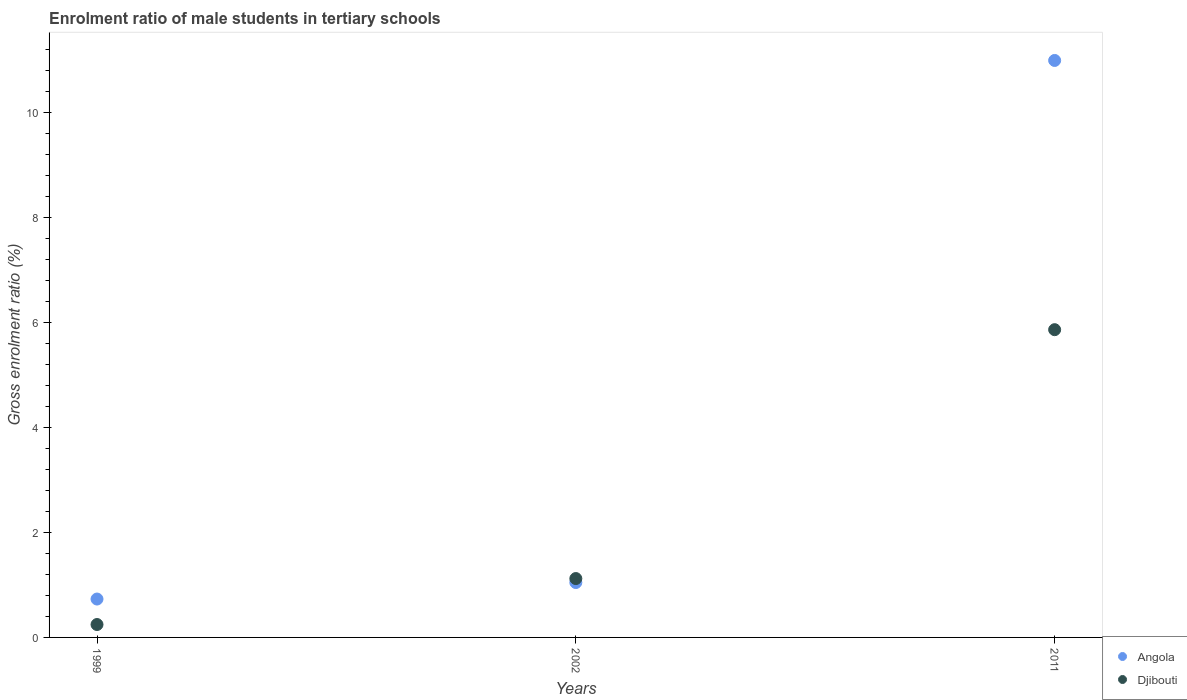How many different coloured dotlines are there?
Ensure brevity in your answer.  2. What is the enrolment ratio of male students in tertiary schools in Djibouti in 2011?
Offer a terse response. 5.86. Across all years, what is the maximum enrolment ratio of male students in tertiary schools in Angola?
Provide a succinct answer. 10.99. Across all years, what is the minimum enrolment ratio of male students in tertiary schools in Angola?
Ensure brevity in your answer.  0.73. In which year was the enrolment ratio of male students in tertiary schools in Djibouti maximum?
Offer a very short reply. 2011. What is the total enrolment ratio of male students in tertiary schools in Angola in the graph?
Your answer should be very brief. 12.76. What is the difference between the enrolment ratio of male students in tertiary schools in Djibouti in 2002 and that in 2011?
Give a very brief answer. -4.74. What is the difference between the enrolment ratio of male students in tertiary schools in Djibouti in 2011 and the enrolment ratio of male students in tertiary schools in Angola in 1999?
Give a very brief answer. 5.13. What is the average enrolment ratio of male students in tertiary schools in Angola per year?
Offer a very short reply. 4.25. In the year 2002, what is the difference between the enrolment ratio of male students in tertiary schools in Djibouti and enrolment ratio of male students in tertiary schools in Angola?
Offer a terse response. 0.08. What is the ratio of the enrolment ratio of male students in tertiary schools in Angola in 1999 to that in 2011?
Provide a short and direct response. 0.07. Is the difference between the enrolment ratio of male students in tertiary schools in Djibouti in 1999 and 2002 greater than the difference between the enrolment ratio of male students in tertiary schools in Angola in 1999 and 2002?
Ensure brevity in your answer.  No. What is the difference between the highest and the second highest enrolment ratio of male students in tertiary schools in Angola?
Your response must be concise. 9.94. What is the difference between the highest and the lowest enrolment ratio of male students in tertiary schools in Djibouti?
Provide a short and direct response. 5.61. Is the sum of the enrolment ratio of male students in tertiary schools in Angola in 1999 and 2002 greater than the maximum enrolment ratio of male students in tertiary schools in Djibouti across all years?
Your response must be concise. No. Does the enrolment ratio of male students in tertiary schools in Angola monotonically increase over the years?
Offer a terse response. Yes. Is the enrolment ratio of male students in tertiary schools in Angola strictly greater than the enrolment ratio of male students in tertiary schools in Djibouti over the years?
Offer a terse response. No. Is the enrolment ratio of male students in tertiary schools in Djibouti strictly less than the enrolment ratio of male students in tertiary schools in Angola over the years?
Provide a short and direct response. No. How many dotlines are there?
Give a very brief answer. 2. How many years are there in the graph?
Make the answer very short. 3. What is the difference between two consecutive major ticks on the Y-axis?
Provide a succinct answer. 2. Does the graph contain grids?
Give a very brief answer. No. Where does the legend appear in the graph?
Keep it short and to the point. Bottom right. How many legend labels are there?
Provide a succinct answer. 2. How are the legend labels stacked?
Your answer should be compact. Vertical. What is the title of the graph?
Your answer should be very brief. Enrolment ratio of male students in tertiary schools. Does "Libya" appear as one of the legend labels in the graph?
Give a very brief answer. No. What is the label or title of the X-axis?
Offer a very short reply. Years. What is the label or title of the Y-axis?
Your response must be concise. Gross enrolment ratio (%). What is the Gross enrolment ratio (%) of Angola in 1999?
Your answer should be very brief. 0.73. What is the Gross enrolment ratio (%) in Djibouti in 1999?
Offer a very short reply. 0.25. What is the Gross enrolment ratio (%) of Angola in 2002?
Your answer should be compact. 1.05. What is the Gross enrolment ratio (%) in Djibouti in 2002?
Make the answer very short. 1.12. What is the Gross enrolment ratio (%) in Angola in 2011?
Give a very brief answer. 10.99. What is the Gross enrolment ratio (%) of Djibouti in 2011?
Keep it short and to the point. 5.86. Across all years, what is the maximum Gross enrolment ratio (%) of Angola?
Give a very brief answer. 10.99. Across all years, what is the maximum Gross enrolment ratio (%) of Djibouti?
Provide a succinct answer. 5.86. Across all years, what is the minimum Gross enrolment ratio (%) in Angola?
Offer a terse response. 0.73. Across all years, what is the minimum Gross enrolment ratio (%) in Djibouti?
Provide a succinct answer. 0.25. What is the total Gross enrolment ratio (%) in Angola in the graph?
Your answer should be very brief. 12.76. What is the total Gross enrolment ratio (%) in Djibouti in the graph?
Offer a very short reply. 7.23. What is the difference between the Gross enrolment ratio (%) in Angola in 1999 and that in 2002?
Your answer should be compact. -0.31. What is the difference between the Gross enrolment ratio (%) of Djibouti in 1999 and that in 2002?
Make the answer very short. -0.88. What is the difference between the Gross enrolment ratio (%) in Angola in 1999 and that in 2011?
Offer a terse response. -10.25. What is the difference between the Gross enrolment ratio (%) of Djibouti in 1999 and that in 2011?
Offer a terse response. -5.61. What is the difference between the Gross enrolment ratio (%) of Angola in 2002 and that in 2011?
Provide a succinct answer. -9.94. What is the difference between the Gross enrolment ratio (%) in Djibouti in 2002 and that in 2011?
Give a very brief answer. -4.74. What is the difference between the Gross enrolment ratio (%) in Angola in 1999 and the Gross enrolment ratio (%) in Djibouti in 2002?
Provide a succinct answer. -0.39. What is the difference between the Gross enrolment ratio (%) in Angola in 1999 and the Gross enrolment ratio (%) in Djibouti in 2011?
Provide a short and direct response. -5.13. What is the difference between the Gross enrolment ratio (%) of Angola in 2002 and the Gross enrolment ratio (%) of Djibouti in 2011?
Your answer should be very brief. -4.81. What is the average Gross enrolment ratio (%) in Angola per year?
Offer a terse response. 4.25. What is the average Gross enrolment ratio (%) of Djibouti per year?
Your answer should be very brief. 2.41. In the year 1999, what is the difference between the Gross enrolment ratio (%) in Angola and Gross enrolment ratio (%) in Djibouti?
Ensure brevity in your answer.  0.49. In the year 2002, what is the difference between the Gross enrolment ratio (%) of Angola and Gross enrolment ratio (%) of Djibouti?
Make the answer very short. -0.08. In the year 2011, what is the difference between the Gross enrolment ratio (%) of Angola and Gross enrolment ratio (%) of Djibouti?
Keep it short and to the point. 5.13. What is the ratio of the Gross enrolment ratio (%) in Angola in 1999 to that in 2002?
Your answer should be compact. 0.7. What is the ratio of the Gross enrolment ratio (%) in Djibouti in 1999 to that in 2002?
Offer a very short reply. 0.22. What is the ratio of the Gross enrolment ratio (%) in Angola in 1999 to that in 2011?
Keep it short and to the point. 0.07. What is the ratio of the Gross enrolment ratio (%) in Djibouti in 1999 to that in 2011?
Your answer should be very brief. 0.04. What is the ratio of the Gross enrolment ratio (%) of Angola in 2002 to that in 2011?
Provide a succinct answer. 0.1. What is the ratio of the Gross enrolment ratio (%) of Djibouti in 2002 to that in 2011?
Keep it short and to the point. 0.19. What is the difference between the highest and the second highest Gross enrolment ratio (%) in Angola?
Provide a succinct answer. 9.94. What is the difference between the highest and the second highest Gross enrolment ratio (%) of Djibouti?
Offer a very short reply. 4.74. What is the difference between the highest and the lowest Gross enrolment ratio (%) of Angola?
Your answer should be very brief. 10.25. What is the difference between the highest and the lowest Gross enrolment ratio (%) of Djibouti?
Keep it short and to the point. 5.61. 